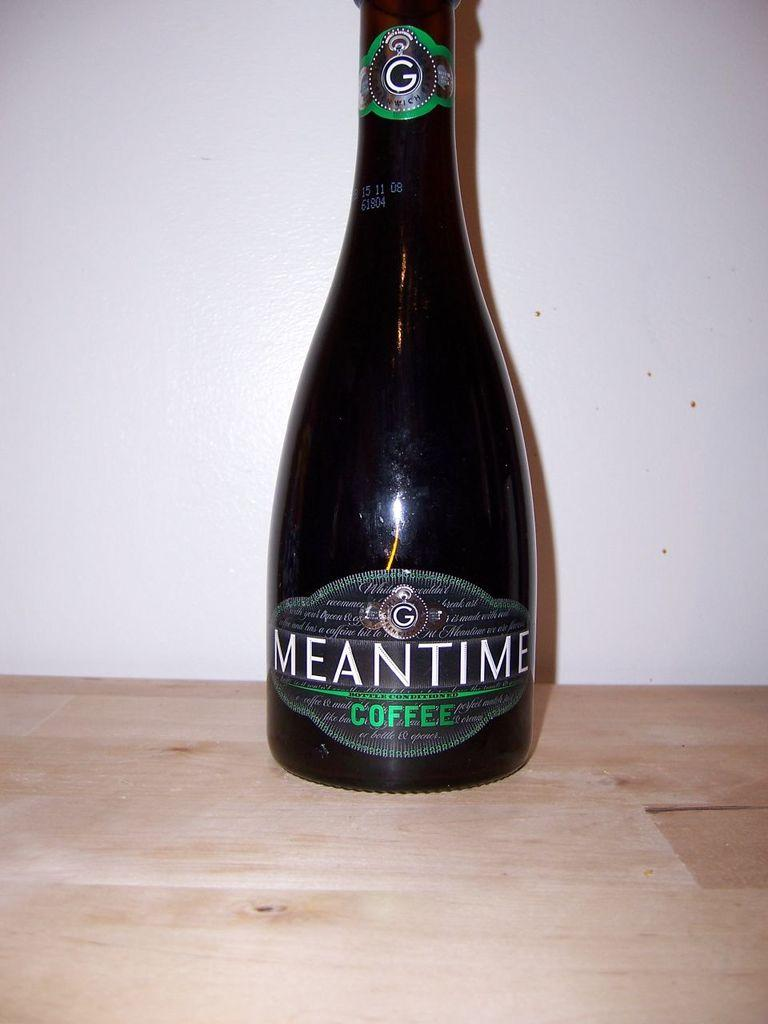Provide a one-sentence caption for the provided image. A bottle of Meantime Coffee on a wooden table. 